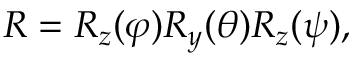Convert formula to latex. <formula><loc_0><loc_0><loc_500><loc_500>R = R _ { z } ( \varphi ) R _ { y } ( \theta ) R _ { z } ( \psi ) ,</formula> 